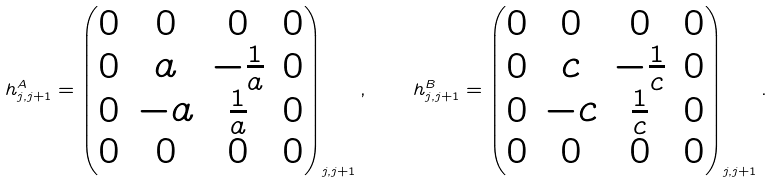Convert formula to latex. <formula><loc_0><loc_0><loc_500><loc_500>h _ { j , j + 1 } ^ { A } = \begin{pmatrix} 0 & 0 & 0 & 0 \\ 0 & a & - \frac { 1 } { a } & 0 \\ 0 & - a & \frac { 1 } { a } & 0 \\ 0 & 0 & 0 & 0 \\ \end{pmatrix} _ { j , j + 1 } , \quad h _ { j , j + 1 } ^ { B } = \begin{pmatrix} 0 & 0 & 0 & 0 \\ 0 & c & - \frac { 1 } { c } & 0 \\ 0 & - c & \frac { 1 } { c } & 0 \\ 0 & 0 & 0 & 0 \\ \end{pmatrix} _ { j , j + 1 } .</formula> 